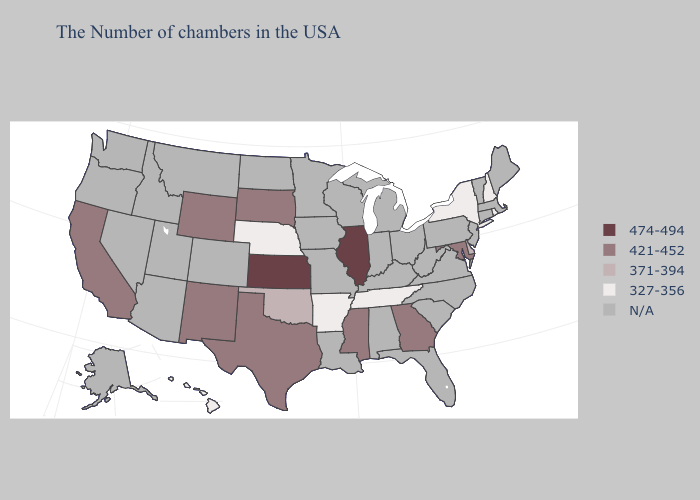What is the value of Maryland?
Quick response, please. 421-452. Which states have the lowest value in the South?
Write a very short answer. Tennessee, Arkansas. What is the highest value in states that border Oklahoma?
Short answer required. 474-494. Which states have the lowest value in the Northeast?
Be succinct. Rhode Island, New Hampshire, New York. What is the value of Nebraska?
Write a very short answer. 327-356. Name the states that have a value in the range 474-494?
Answer briefly. Illinois, Kansas. Name the states that have a value in the range N/A?
Be succinct. Maine, Massachusetts, Vermont, Connecticut, New Jersey, Pennsylvania, Virginia, North Carolina, South Carolina, West Virginia, Ohio, Florida, Michigan, Kentucky, Indiana, Alabama, Wisconsin, Louisiana, Missouri, Minnesota, Iowa, North Dakota, Colorado, Utah, Montana, Arizona, Idaho, Nevada, Washington, Oregon, Alaska. What is the value of South Dakota?
Concise answer only. 421-452. Name the states that have a value in the range 421-452?
Write a very short answer. Maryland, Georgia, Mississippi, Texas, South Dakota, Wyoming, New Mexico, California. Name the states that have a value in the range N/A?
Keep it brief. Maine, Massachusetts, Vermont, Connecticut, New Jersey, Pennsylvania, Virginia, North Carolina, South Carolina, West Virginia, Ohio, Florida, Michigan, Kentucky, Indiana, Alabama, Wisconsin, Louisiana, Missouri, Minnesota, Iowa, North Dakota, Colorado, Utah, Montana, Arizona, Idaho, Nevada, Washington, Oregon, Alaska. Is the legend a continuous bar?
Be succinct. No. 